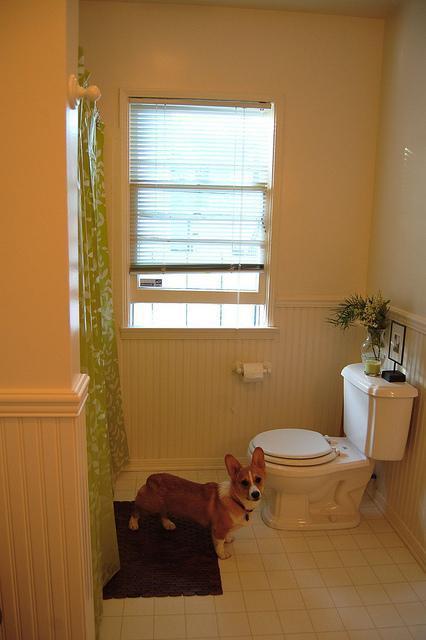How many animals are in this photo?
Give a very brief answer. 1. 